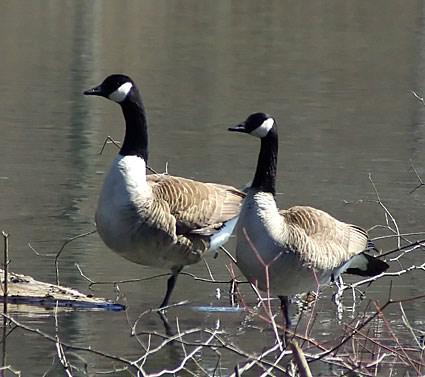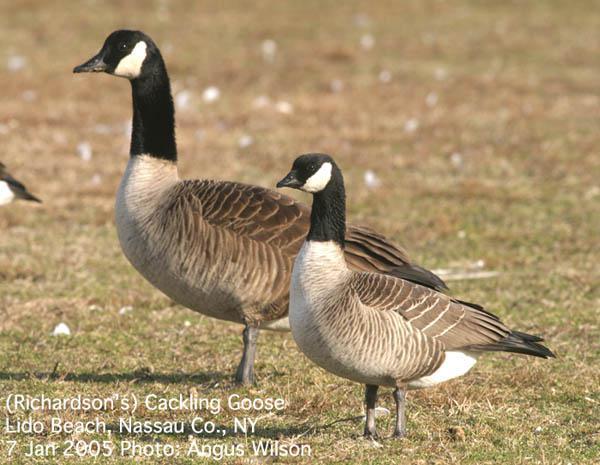The first image is the image on the left, the second image is the image on the right. Given the left and right images, does the statement "All images show birds that are flying." hold true? Answer yes or no. No. 